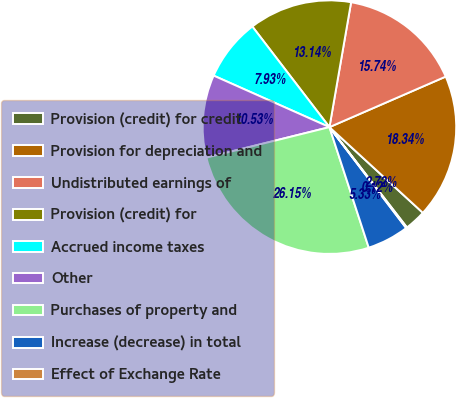Convert chart. <chart><loc_0><loc_0><loc_500><loc_500><pie_chart><fcel>Provision (credit) for credit<fcel>Provision for depreciation and<fcel>Undistributed earnings of<fcel>Provision (credit) for<fcel>Accrued income taxes<fcel>Other<fcel>Purchases of property and<fcel>Increase (decrease) in total<fcel>Effect of Exchange Rate<nl><fcel>2.72%<fcel>18.34%<fcel>15.74%<fcel>13.14%<fcel>7.93%<fcel>10.53%<fcel>26.15%<fcel>5.33%<fcel>0.12%<nl></chart> 